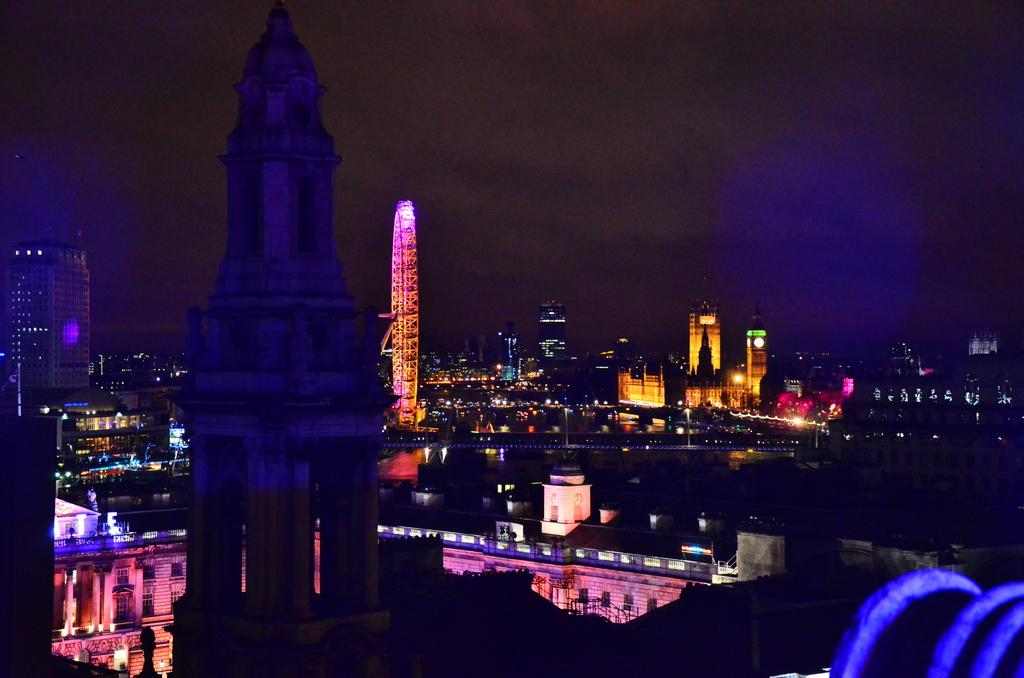What type of structures are present in the image? There are many buildings and skyscrapers in the image. What is the main attraction in the middle of the image? There is a giant wheel in the middle of the image. What can be seen at the top of the image? The sky is visible at the top of the image. How many beams are supporting the giant wheel in the image? There is no information about beams in the image, as it only shows a giant wheel and surrounding buildings. Can you see any rabbits hopping around in the image? There are no rabbits present in the image; it features a giant wheel and buildings. 